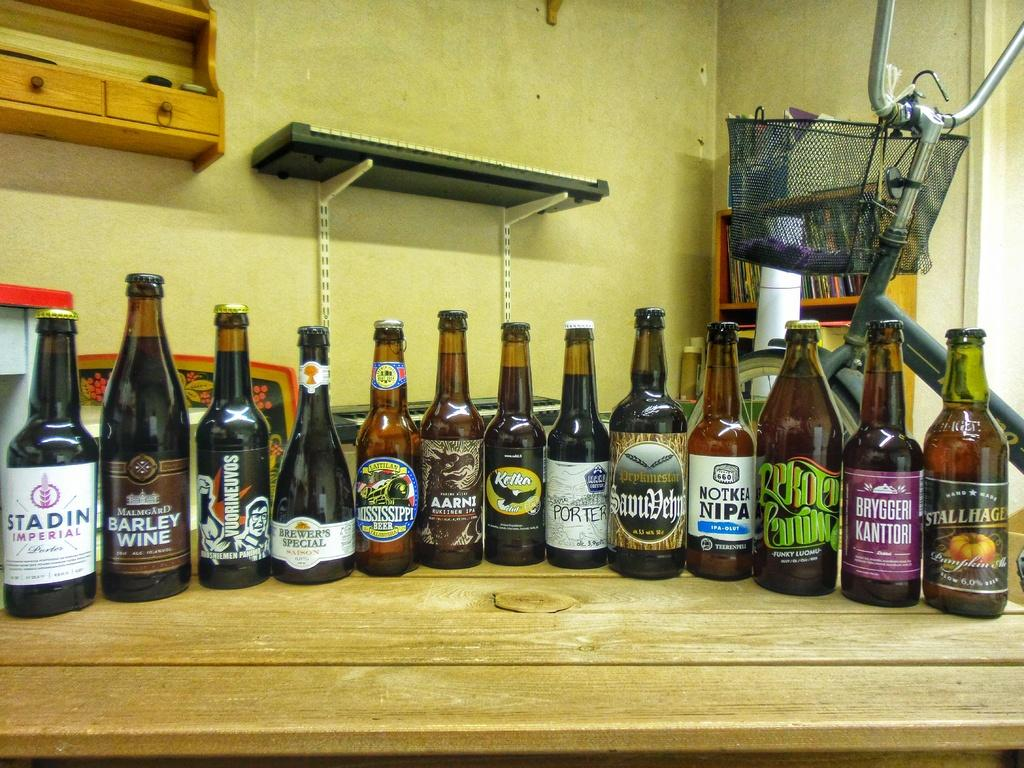<image>
Summarize the visual content of the image. A collection of bottles, including Stadin Imperial, sit on a counter. 